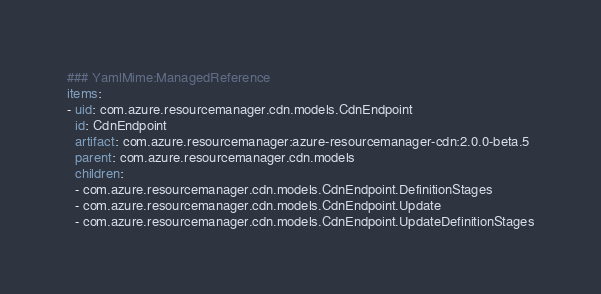Convert code to text. <code><loc_0><loc_0><loc_500><loc_500><_YAML_>### YamlMime:ManagedReference
items:
- uid: com.azure.resourcemanager.cdn.models.CdnEndpoint
  id: CdnEndpoint
  artifact: com.azure.resourcemanager:azure-resourcemanager-cdn:2.0.0-beta.5
  parent: com.azure.resourcemanager.cdn.models
  children:
  - com.azure.resourcemanager.cdn.models.CdnEndpoint.DefinitionStages
  - com.azure.resourcemanager.cdn.models.CdnEndpoint.Update
  - com.azure.resourcemanager.cdn.models.CdnEndpoint.UpdateDefinitionStages</code> 